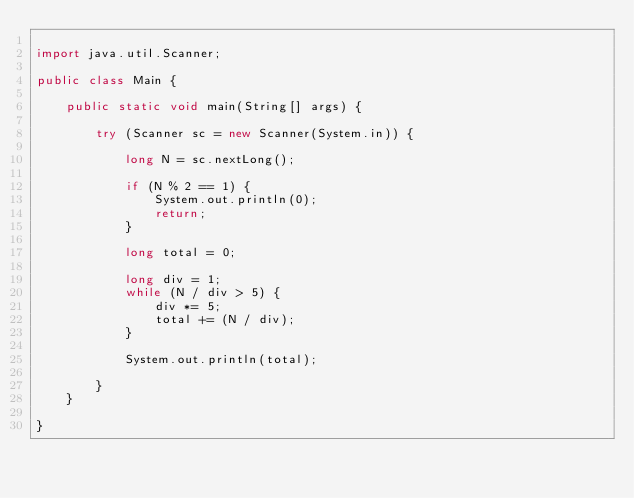Convert code to text. <code><loc_0><loc_0><loc_500><loc_500><_Java_>
import java.util.Scanner;

public class Main {

	public static void main(String[] args) {

		try (Scanner sc = new Scanner(System.in)) {

			long N = sc.nextLong();

			if (N % 2 == 1) {
				System.out.println(0);
				return;
			}

			long total = 0;

			long div = 1;
			while (N / div > 5) {
				div *= 5;
				total += (N / div);
			}

			System.out.println(total);

		}
	}

}
</code> 